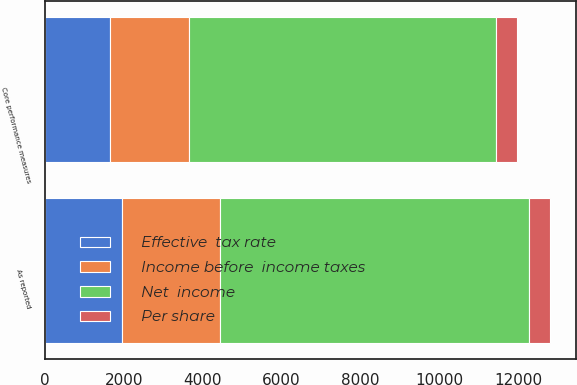<chart> <loc_0><loc_0><loc_500><loc_500><stacked_bar_chart><ecel><fcel>As reported<fcel>Core performance measures<nl><fcel>Net  income<fcel>7819<fcel>7780<nl><fcel>Per share<fcel>547<fcel>531<nl><fcel>Income before  income taxes<fcel>2473<fcel>1995<nl><fcel>Effective  tax rate<fcel>1961<fcel>1656<nl></chart> 